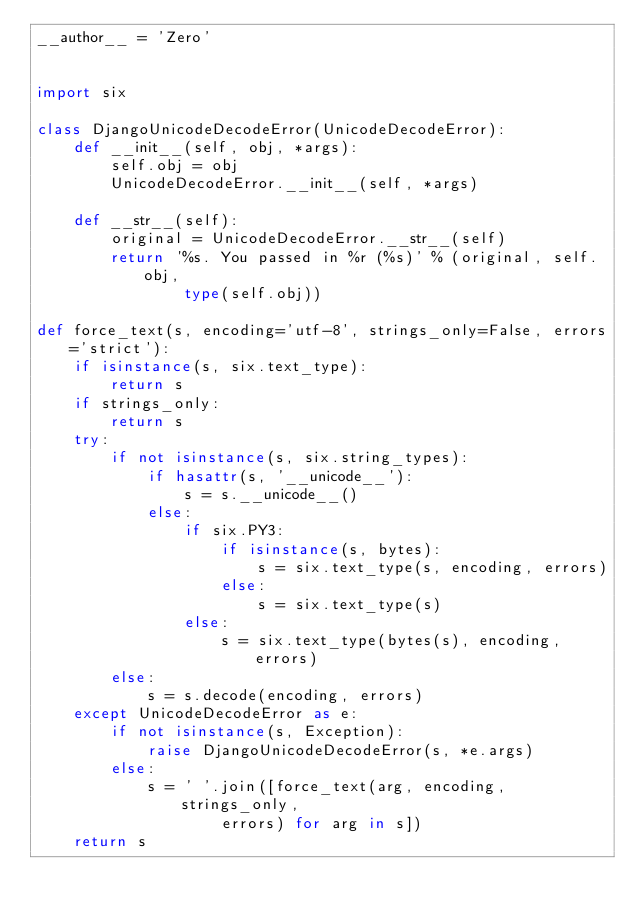Convert code to text. <code><loc_0><loc_0><loc_500><loc_500><_Python_>__author__ = 'Zero'


import six

class DjangoUnicodeDecodeError(UnicodeDecodeError):
    def __init__(self, obj, *args):
        self.obj = obj
        UnicodeDecodeError.__init__(self, *args)

    def __str__(self):
        original = UnicodeDecodeError.__str__(self)
        return '%s. You passed in %r (%s)' % (original, self.obj,
                type(self.obj))

def force_text(s, encoding='utf-8', strings_only=False, errors='strict'):
    if isinstance(s, six.text_type):
        return s
    if strings_only:
        return s
    try:
        if not isinstance(s, six.string_types):
            if hasattr(s, '__unicode__'):
                s = s.__unicode__()
            else:
                if six.PY3:
                    if isinstance(s, bytes):
                        s = six.text_type(s, encoding, errors)
                    else:
                        s = six.text_type(s)
                else:
                    s = six.text_type(bytes(s), encoding, errors)
        else:
            s = s.decode(encoding, errors)
    except UnicodeDecodeError as e:
        if not isinstance(s, Exception):
            raise DjangoUnicodeDecodeError(s, *e.args)
        else:
            s = ' '.join([force_text(arg, encoding, strings_only,
                    errors) for arg in s])
    return s
</code> 